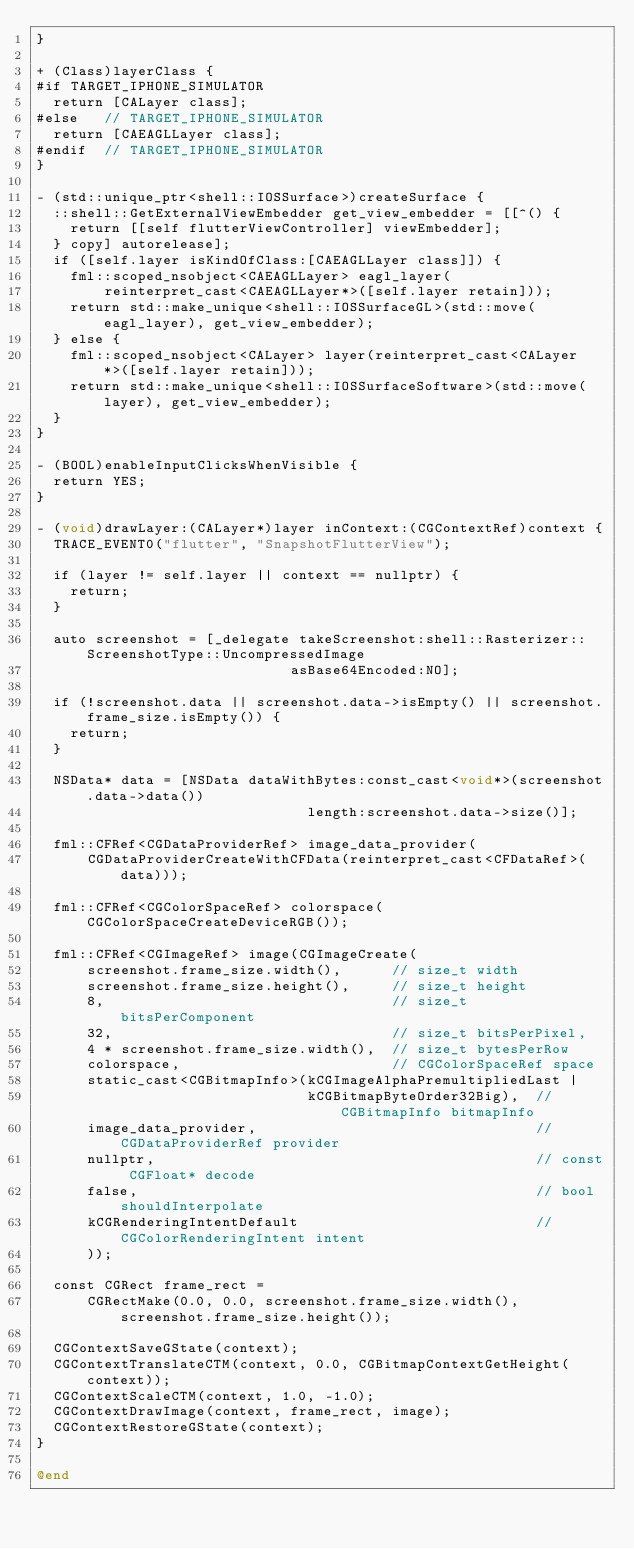Convert code to text. <code><loc_0><loc_0><loc_500><loc_500><_ObjectiveC_>}

+ (Class)layerClass {
#if TARGET_IPHONE_SIMULATOR
  return [CALayer class];
#else   // TARGET_IPHONE_SIMULATOR
  return [CAEAGLLayer class];
#endif  // TARGET_IPHONE_SIMULATOR
}

- (std::unique_ptr<shell::IOSSurface>)createSurface {
  ::shell::GetExternalViewEmbedder get_view_embedder = [[^() {
    return [[self flutterViewController] viewEmbedder];
  } copy] autorelease];
  if ([self.layer isKindOfClass:[CAEAGLLayer class]]) {
    fml::scoped_nsobject<CAEAGLLayer> eagl_layer(
        reinterpret_cast<CAEAGLLayer*>([self.layer retain]));
    return std::make_unique<shell::IOSSurfaceGL>(std::move(eagl_layer), get_view_embedder);
  } else {
    fml::scoped_nsobject<CALayer> layer(reinterpret_cast<CALayer*>([self.layer retain]));
    return std::make_unique<shell::IOSSurfaceSoftware>(std::move(layer), get_view_embedder);
  }
}

- (BOOL)enableInputClicksWhenVisible {
  return YES;
}

- (void)drawLayer:(CALayer*)layer inContext:(CGContextRef)context {
  TRACE_EVENT0("flutter", "SnapshotFlutterView");

  if (layer != self.layer || context == nullptr) {
    return;
  }

  auto screenshot = [_delegate takeScreenshot:shell::Rasterizer::ScreenshotType::UncompressedImage
                              asBase64Encoded:NO];

  if (!screenshot.data || screenshot.data->isEmpty() || screenshot.frame_size.isEmpty()) {
    return;
  }

  NSData* data = [NSData dataWithBytes:const_cast<void*>(screenshot.data->data())
                                length:screenshot.data->size()];

  fml::CFRef<CGDataProviderRef> image_data_provider(
      CGDataProviderCreateWithCFData(reinterpret_cast<CFDataRef>(data)));

  fml::CFRef<CGColorSpaceRef> colorspace(CGColorSpaceCreateDeviceRGB());

  fml::CFRef<CGImageRef> image(CGImageCreate(
      screenshot.frame_size.width(),      // size_t width
      screenshot.frame_size.height(),     // size_t height
      8,                                  // size_t bitsPerComponent
      32,                                 // size_t bitsPerPixel,
      4 * screenshot.frame_size.width(),  // size_t bytesPerRow
      colorspace,                         // CGColorSpaceRef space
      static_cast<CGBitmapInfo>(kCGImageAlphaPremultipliedLast |
                                kCGBitmapByteOrder32Big),  // CGBitmapInfo bitmapInfo
      image_data_provider,                                 // CGDataProviderRef provider
      nullptr,                                             // const CGFloat* decode
      false,                                               // bool shouldInterpolate
      kCGRenderingIntentDefault                            // CGColorRenderingIntent intent
      ));

  const CGRect frame_rect =
      CGRectMake(0.0, 0.0, screenshot.frame_size.width(), screenshot.frame_size.height());

  CGContextSaveGState(context);
  CGContextTranslateCTM(context, 0.0, CGBitmapContextGetHeight(context));
  CGContextScaleCTM(context, 1.0, -1.0);
  CGContextDrawImage(context, frame_rect, image);
  CGContextRestoreGState(context);
}

@end
</code> 